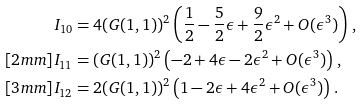Convert formula to latex. <formula><loc_0><loc_0><loc_500><loc_500>I _ { 1 0 } & = 4 ( G ( 1 , 1 ) ) ^ { 2 } \left ( \frac { 1 } { 2 } - \frac { 5 } { 2 } \epsilon + \frac { 9 } { 2 } \epsilon ^ { 2 } + O ( \epsilon ^ { 3 } ) \right ) \, , \\ [ 2 m m ] I _ { 1 1 } & = ( G ( 1 , 1 ) ) ^ { 2 } \left ( - 2 + 4 \epsilon - 2 \epsilon ^ { 2 } + O ( \epsilon ^ { 3 } ) \right ) \, , \\ [ 3 m m ] I _ { 1 2 } & = 2 ( G ( 1 , 1 ) ) ^ { 2 } \left ( 1 - 2 \epsilon + 4 \epsilon ^ { 2 } + O ( \epsilon ^ { 3 } ) \right ) \, .</formula> 